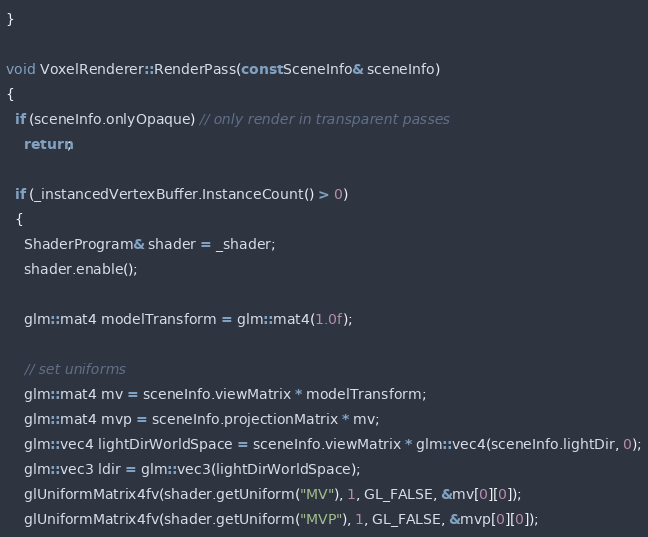Convert code to text. <code><loc_0><loc_0><loc_500><loc_500><_C++_>}

void VoxelRenderer::RenderPass(const SceneInfo& sceneInfo)
{
  if (sceneInfo.onlyOpaque) // only render in transparent passes
    return;

  if (_instancedVertexBuffer.InstanceCount() > 0)
  {
    ShaderProgram& shader = _shader;
    shader.enable();

    glm::mat4 modelTransform = glm::mat4(1.0f);

    // set uniforms
    glm::mat4 mv = sceneInfo.viewMatrix * modelTransform;
    glm::mat4 mvp = sceneInfo.projectionMatrix * mv;
    glm::vec4 lightDirWorldSpace = sceneInfo.viewMatrix * glm::vec4(sceneInfo.lightDir, 0);
    glm::vec3 ldir = glm::vec3(lightDirWorldSpace);
    glUniformMatrix4fv(shader.getUniform("MV"), 1, GL_FALSE, &mv[0][0]);
    glUniformMatrix4fv(shader.getUniform("MVP"), 1, GL_FALSE, &mvp[0][0]);</code> 